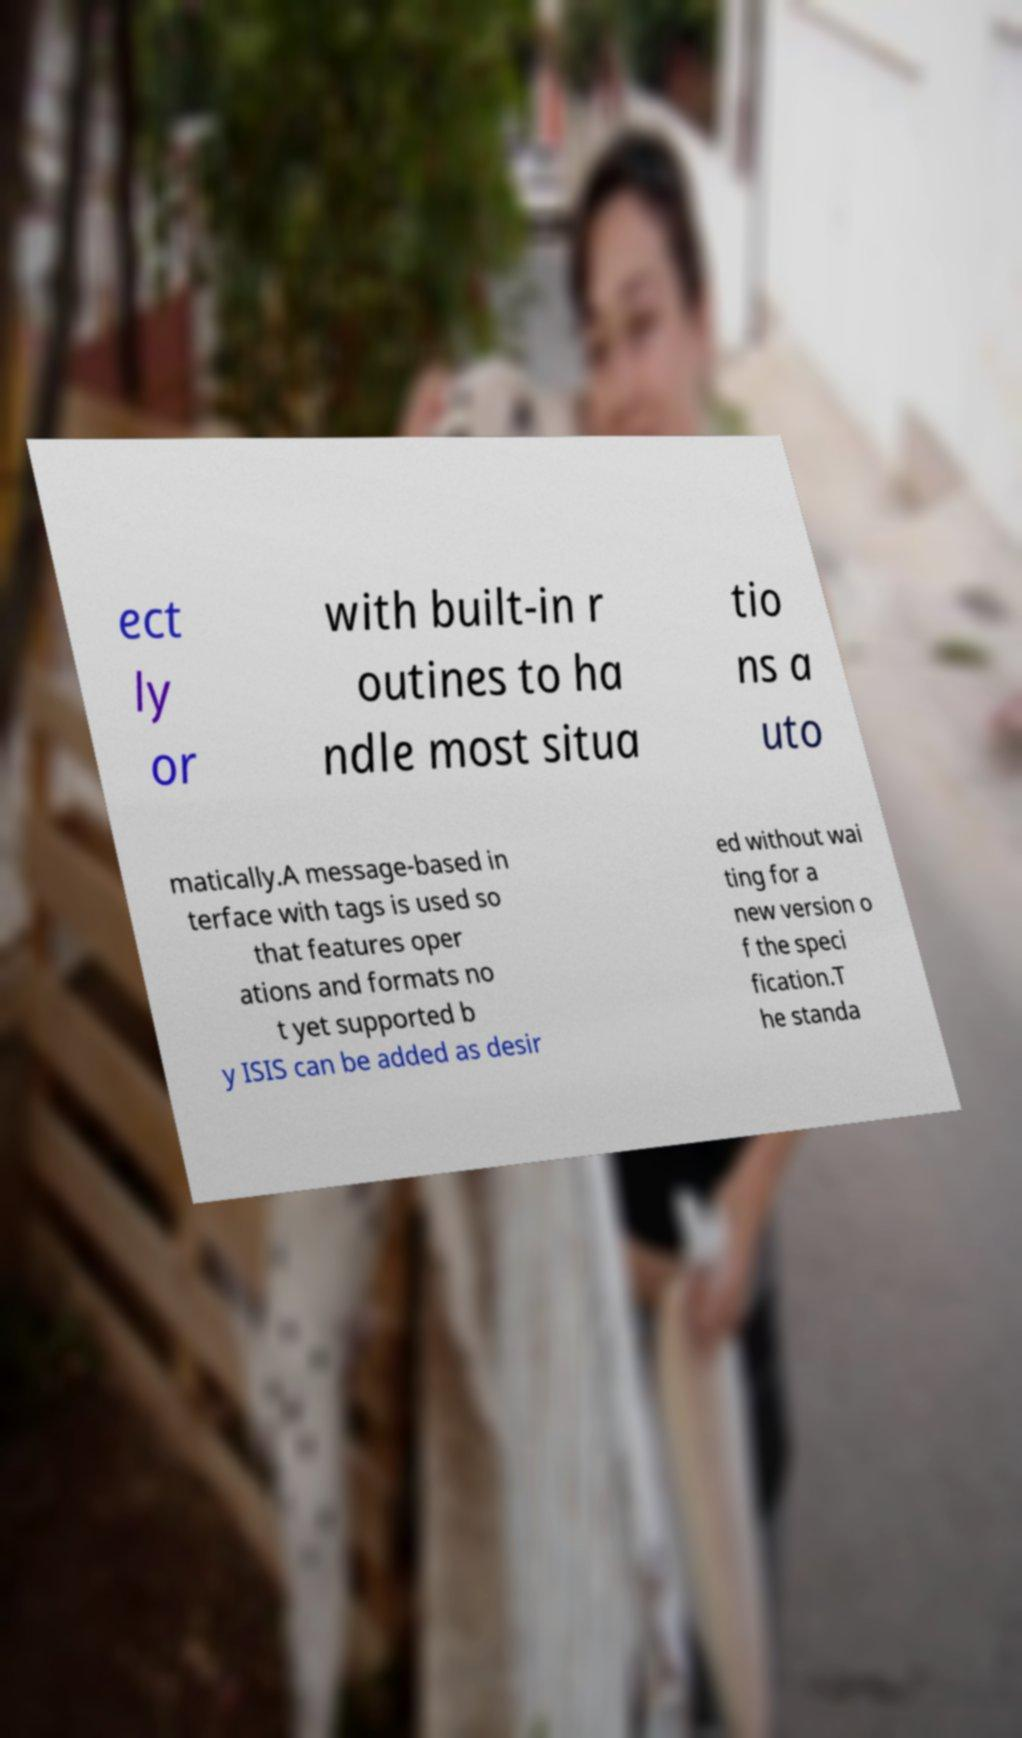Can you accurately transcribe the text from the provided image for me? ect ly or with built-in r outines to ha ndle most situa tio ns a uto matically.A message-based in terface with tags is used so that features oper ations and formats no t yet supported b y ISIS can be added as desir ed without wai ting for a new version o f the speci fication.T he standa 